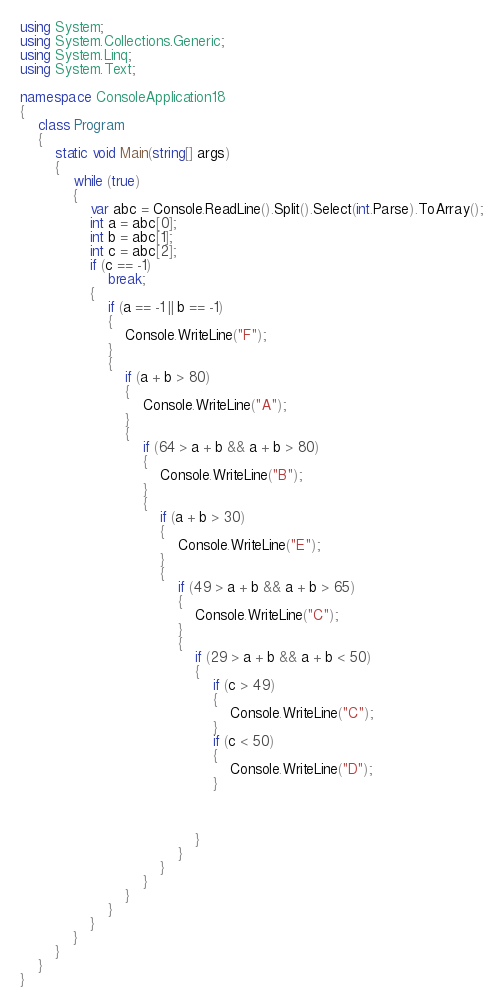<code> <loc_0><loc_0><loc_500><loc_500><_C#_>using System;
using System.Collections.Generic;
using System.Linq;
using System.Text;

namespace ConsoleApplication18
{
    class Program
    {
        static void Main(string[] args)
        {
            while (true)
            {
                var abc = Console.ReadLine().Split().Select(int.Parse).ToArray();
                int a = abc[0];
                int b = abc[1];
                int c = abc[2];
                if (c == -1)
                    break;
                {
                    if (a == -1 || b == -1)
                    {
                        Console.WriteLine("F");
                    }
                    {
                        if (a + b > 80)
                        {
                            Console.WriteLine("A");
                        }
                        {
                            if (64 > a + b && a + b > 80)
                            {
                                Console.WriteLine("B");
                            }
                            {
                                if (a + b > 30)
                                {
                                    Console.WriteLine("E");
                                }
                                {
                                    if (49 > a + b && a + b > 65)
                                    {
                                        Console.WriteLine("C");
                                    }
                                    {
                                        if (29 > a + b && a + b < 50)
                                        {
                                            if (c > 49)
                                            {
                                                Console.WriteLine("C");
                                            }
                                            if (c < 50)
                                            {
                                                Console.WriteLine("D");
                                            }



                                        }
                                    }
                                }
                            }
                        }
                    }
                }
            }
        }
    }
}</code> 